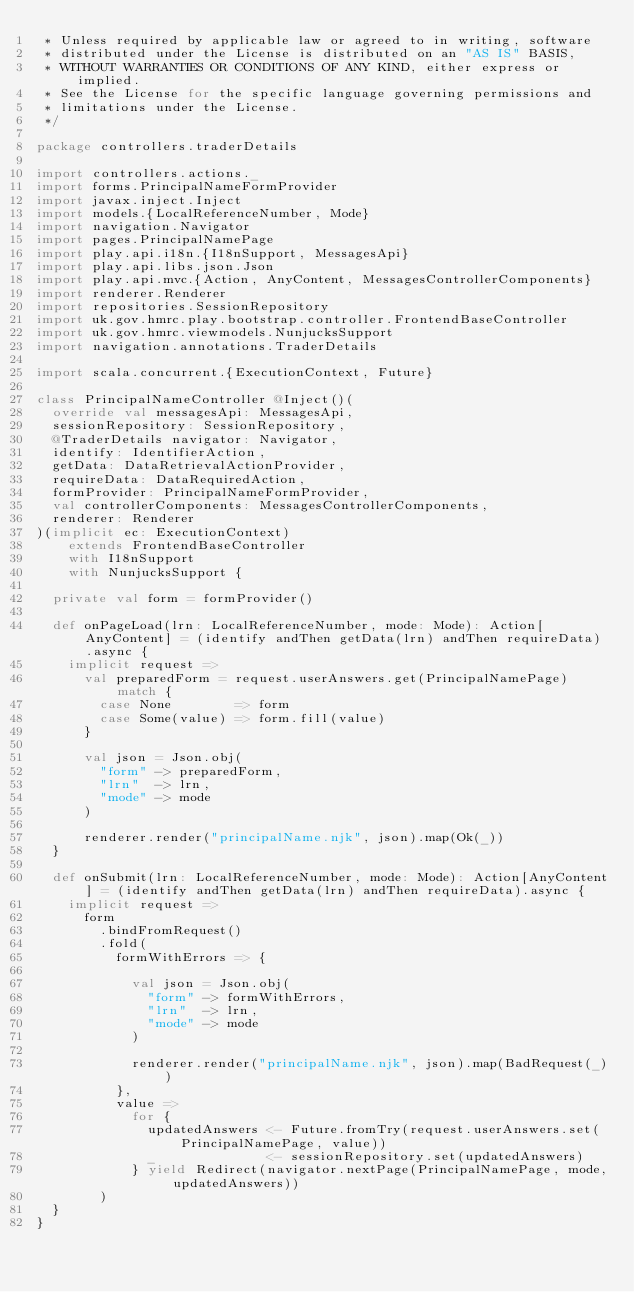Convert code to text. <code><loc_0><loc_0><loc_500><loc_500><_Scala_> * Unless required by applicable law or agreed to in writing, software
 * distributed under the License is distributed on an "AS IS" BASIS,
 * WITHOUT WARRANTIES OR CONDITIONS OF ANY KIND, either express or implied.
 * See the License for the specific language governing permissions and
 * limitations under the License.
 */

package controllers.traderDetails

import controllers.actions._
import forms.PrincipalNameFormProvider
import javax.inject.Inject
import models.{LocalReferenceNumber, Mode}
import navigation.Navigator
import pages.PrincipalNamePage
import play.api.i18n.{I18nSupport, MessagesApi}
import play.api.libs.json.Json
import play.api.mvc.{Action, AnyContent, MessagesControllerComponents}
import renderer.Renderer
import repositories.SessionRepository
import uk.gov.hmrc.play.bootstrap.controller.FrontendBaseController
import uk.gov.hmrc.viewmodels.NunjucksSupport
import navigation.annotations.TraderDetails

import scala.concurrent.{ExecutionContext, Future}

class PrincipalNameController @Inject()(
  override val messagesApi: MessagesApi,
  sessionRepository: SessionRepository,
  @TraderDetails navigator: Navigator,
  identify: IdentifierAction,
  getData: DataRetrievalActionProvider,
  requireData: DataRequiredAction,
  formProvider: PrincipalNameFormProvider,
  val controllerComponents: MessagesControllerComponents,
  renderer: Renderer
)(implicit ec: ExecutionContext)
    extends FrontendBaseController
    with I18nSupport
    with NunjucksSupport {

  private val form = formProvider()

  def onPageLoad(lrn: LocalReferenceNumber, mode: Mode): Action[AnyContent] = (identify andThen getData(lrn) andThen requireData).async {
    implicit request =>
      val preparedForm = request.userAnswers.get(PrincipalNamePage) match {
        case None        => form
        case Some(value) => form.fill(value)
      }

      val json = Json.obj(
        "form" -> preparedForm,
        "lrn"  -> lrn,
        "mode" -> mode
      )

      renderer.render("principalName.njk", json).map(Ok(_))
  }

  def onSubmit(lrn: LocalReferenceNumber, mode: Mode): Action[AnyContent] = (identify andThen getData(lrn) andThen requireData).async {
    implicit request =>
      form
        .bindFromRequest()
        .fold(
          formWithErrors => {

            val json = Json.obj(
              "form" -> formWithErrors,
              "lrn"  -> lrn,
              "mode" -> mode
            )

            renderer.render("principalName.njk", json).map(BadRequest(_))
          },
          value =>
            for {
              updatedAnswers <- Future.fromTry(request.userAnswers.set(PrincipalNamePage, value))
              _              <- sessionRepository.set(updatedAnswers)
            } yield Redirect(navigator.nextPage(PrincipalNamePage, mode, updatedAnswers))
        )
  }
}
</code> 